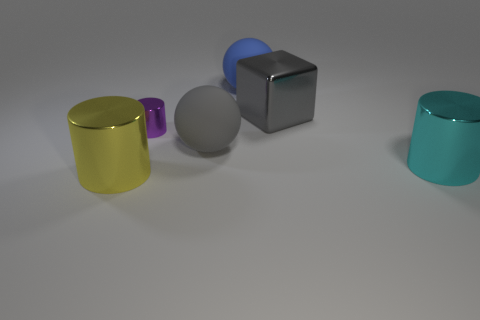Are there any other things that have the same size as the purple metallic cylinder?
Your response must be concise. No. There is a object that is the same color as the large block; what material is it?
Give a very brief answer. Rubber. Is the number of small purple metallic cylinders behind the large blue sphere less than the number of metallic objects in front of the purple metallic cylinder?
Provide a succinct answer. Yes. How many objects are metallic cylinders or big shiny objects left of the large gray metal cube?
Keep it short and to the point. 3. There is a gray cube that is the same size as the yellow shiny cylinder; what material is it?
Your response must be concise. Metal. Are the cyan cylinder and the small cylinder made of the same material?
Offer a terse response. Yes. The metal cylinder that is both in front of the gray sphere and on the left side of the large gray sphere is what color?
Provide a short and direct response. Yellow. There is a large thing that is behind the large gray metallic thing; is its color the same as the large shiny cube?
Give a very brief answer. No. There is a cyan thing that is the same size as the gray shiny cube; what shape is it?
Offer a very short reply. Cylinder. How many other objects are there of the same color as the block?
Ensure brevity in your answer.  1. 